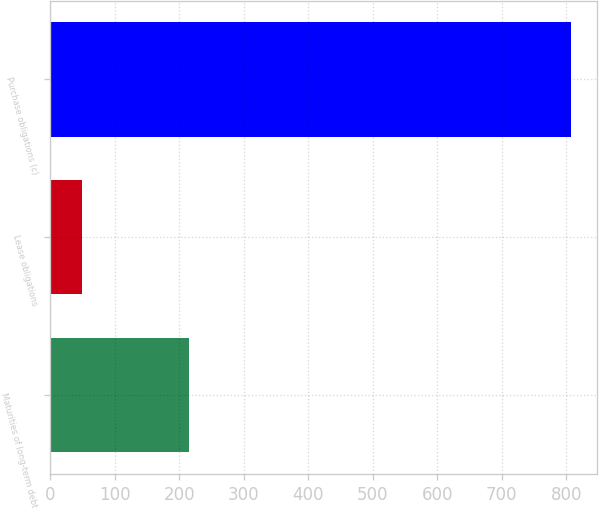<chart> <loc_0><loc_0><loc_500><loc_500><bar_chart><fcel>Maturities of long-term debt<fcel>Lease obligations<fcel>Purchase obligations (c)<nl><fcel>216<fcel>50<fcel>808<nl></chart> 